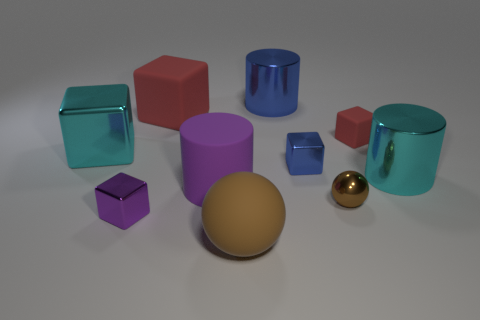Subtract all balls. How many objects are left? 8 Subtract all metallic cylinders. How many cylinders are left? 1 Add 5 tiny brown things. How many tiny brown things are left? 6 Add 8 tiny blue metallic objects. How many tiny blue metallic objects exist? 9 Subtract all cyan blocks. How many blocks are left? 4 Subtract 0 green cylinders. How many objects are left? 10 Subtract 2 blocks. How many blocks are left? 3 Subtract all gray cylinders. Subtract all yellow blocks. How many cylinders are left? 3 Subtract all yellow balls. How many purple cylinders are left? 1 Subtract all big green cylinders. Subtract all blue shiny cubes. How many objects are left? 9 